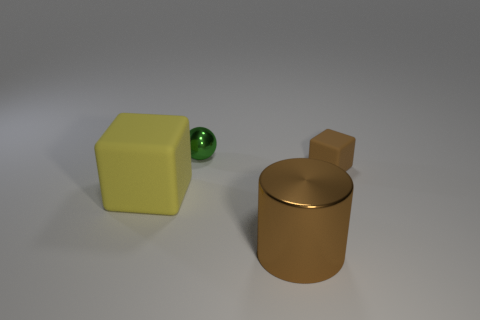How many tiny blocks have the same color as the big metal object?
Provide a short and direct response. 1. What material is the object that is the same color as the tiny block?
Provide a short and direct response. Metal. What material is the brown object that is the same size as the yellow rubber block?
Offer a terse response. Metal. There is a cube right of the matte thing that is to the left of the small object that is behind the brown block; what is its color?
Offer a very short reply. Brown. What shape is the big brown object that is made of the same material as the sphere?
Ensure brevity in your answer.  Cylinder. Are there fewer tiny brown cubes than large blue matte balls?
Make the answer very short. No. Is the material of the big cylinder the same as the yellow object?
Offer a terse response. No. What number of other things are there of the same color as the tiny matte cube?
Your answer should be very brief. 1. Are there more small green objects than gray metallic cylinders?
Your response must be concise. Yes. There is a metal ball; is it the same size as the brown thing in front of the big yellow cube?
Ensure brevity in your answer.  No. 